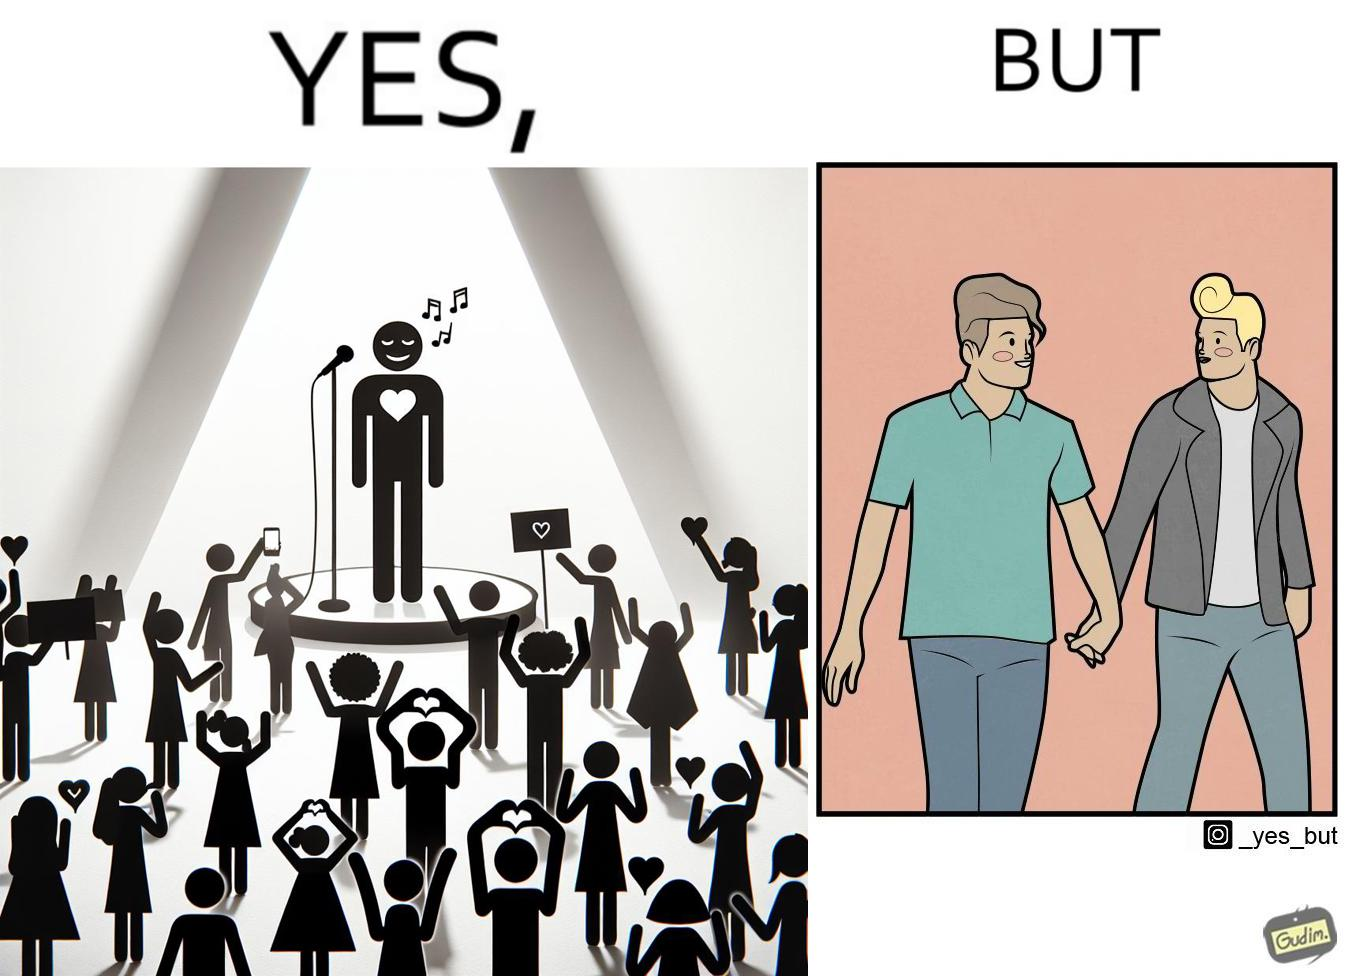What does this image depict? The image is funny because while the girls loves the man, he likes other men instead of women. 